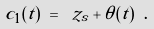Convert formula to latex. <formula><loc_0><loc_0><loc_500><loc_500>c _ { 1 } ( t ) \ = \ z _ { s } + \theta ( t ) \ .</formula> 